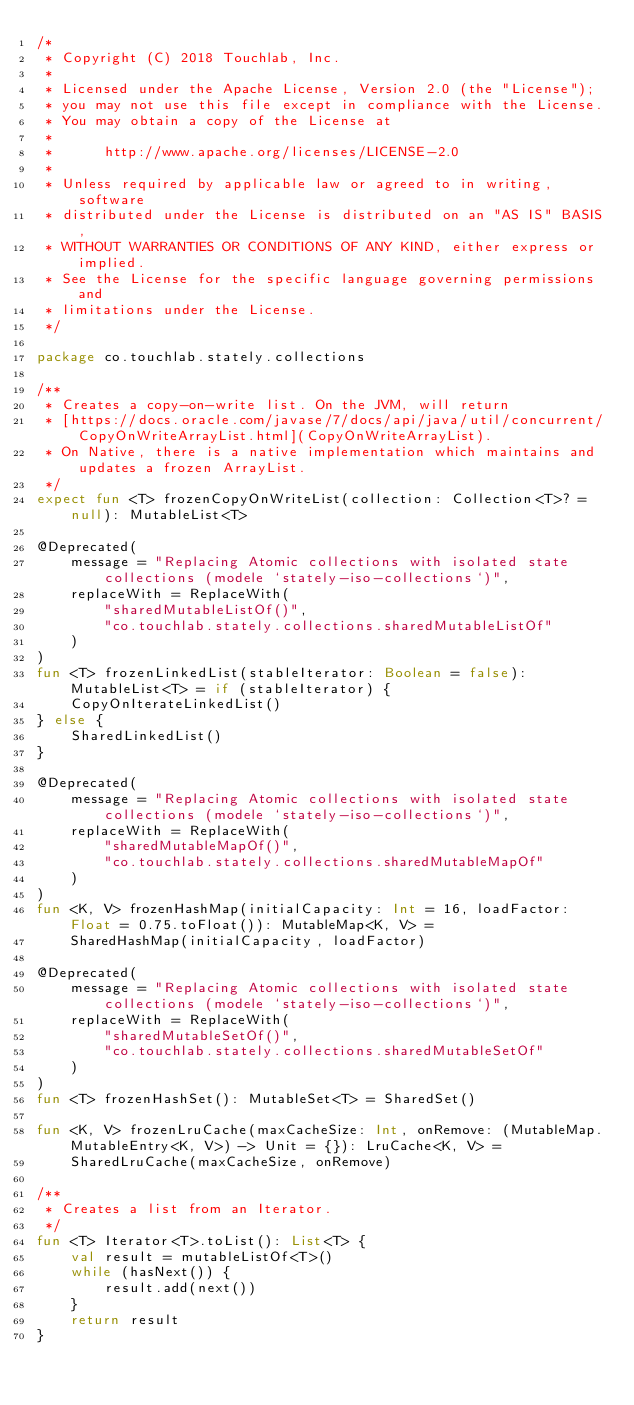Convert code to text. <code><loc_0><loc_0><loc_500><loc_500><_Kotlin_>/*
 * Copyright (C) 2018 Touchlab, Inc.
 *
 * Licensed under the Apache License, Version 2.0 (the "License");
 * you may not use this file except in compliance with the License.
 * You may obtain a copy of the License at
 *
 *      http://www.apache.org/licenses/LICENSE-2.0
 *
 * Unless required by applicable law or agreed to in writing, software
 * distributed under the License is distributed on an "AS IS" BASIS,
 * WITHOUT WARRANTIES OR CONDITIONS OF ANY KIND, either express or implied.
 * See the License for the specific language governing permissions and
 * limitations under the License.
 */

package co.touchlab.stately.collections

/**
 * Creates a copy-on-write list. On the JVM, will return
 * [https://docs.oracle.com/javase/7/docs/api/java/util/concurrent/CopyOnWriteArrayList.html](CopyOnWriteArrayList).
 * On Native, there is a native implementation which maintains and updates a frozen ArrayList.
 */
expect fun <T> frozenCopyOnWriteList(collection: Collection<T>? = null): MutableList<T>

@Deprecated(
    message = "Replacing Atomic collections with isolated state collections (modele `stately-iso-collections`)",
    replaceWith = ReplaceWith(
        "sharedMutableListOf()",
        "co.touchlab.stately.collections.sharedMutableListOf"
    )
)
fun <T> frozenLinkedList(stableIterator: Boolean = false): MutableList<T> = if (stableIterator) {
    CopyOnIterateLinkedList()
} else {
    SharedLinkedList()
}

@Deprecated(
    message = "Replacing Atomic collections with isolated state collections (modele `stately-iso-collections`)",
    replaceWith = ReplaceWith(
        "sharedMutableMapOf()",
        "co.touchlab.stately.collections.sharedMutableMapOf"
    )
)
fun <K, V> frozenHashMap(initialCapacity: Int = 16, loadFactor: Float = 0.75.toFloat()): MutableMap<K, V> =
    SharedHashMap(initialCapacity, loadFactor)

@Deprecated(
    message = "Replacing Atomic collections with isolated state collections (modele `stately-iso-collections`)",
    replaceWith = ReplaceWith(
        "sharedMutableSetOf()",
        "co.touchlab.stately.collections.sharedMutableSetOf"
    )
)
fun <T> frozenHashSet(): MutableSet<T> = SharedSet()

fun <K, V> frozenLruCache(maxCacheSize: Int, onRemove: (MutableMap.MutableEntry<K, V>) -> Unit = {}): LruCache<K, V> =
    SharedLruCache(maxCacheSize, onRemove)

/**
 * Creates a list from an Iterator.
 */
fun <T> Iterator<T>.toList(): List<T> {
    val result = mutableListOf<T>()
    while (hasNext()) {
        result.add(next())
    }
    return result
}
</code> 